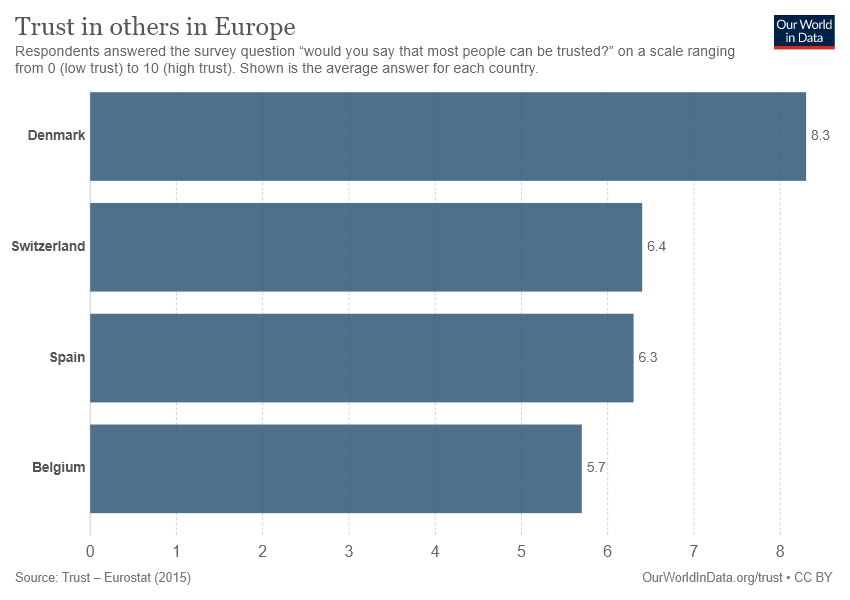Highlight a few significant elements in this photo. Denmark is the country with the longest bar. Switzerland and Spain have the smallest difference between them. 